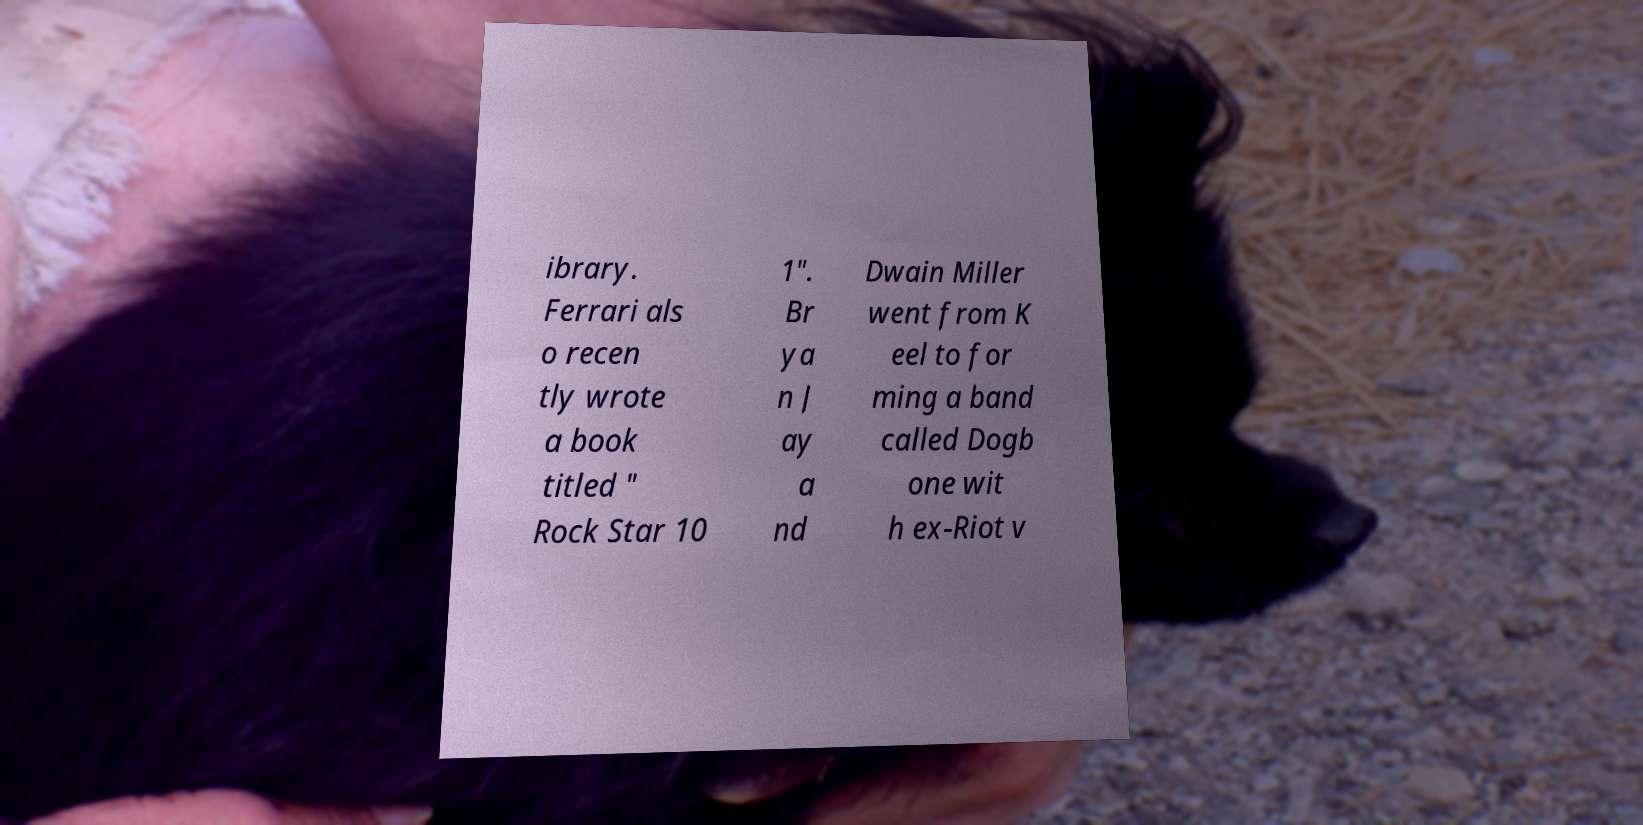Could you extract and type out the text from this image? ibrary. Ferrari als o recen tly wrote a book titled " Rock Star 10 1". Br ya n J ay a nd Dwain Miller went from K eel to for ming a band called Dogb one wit h ex-Riot v 